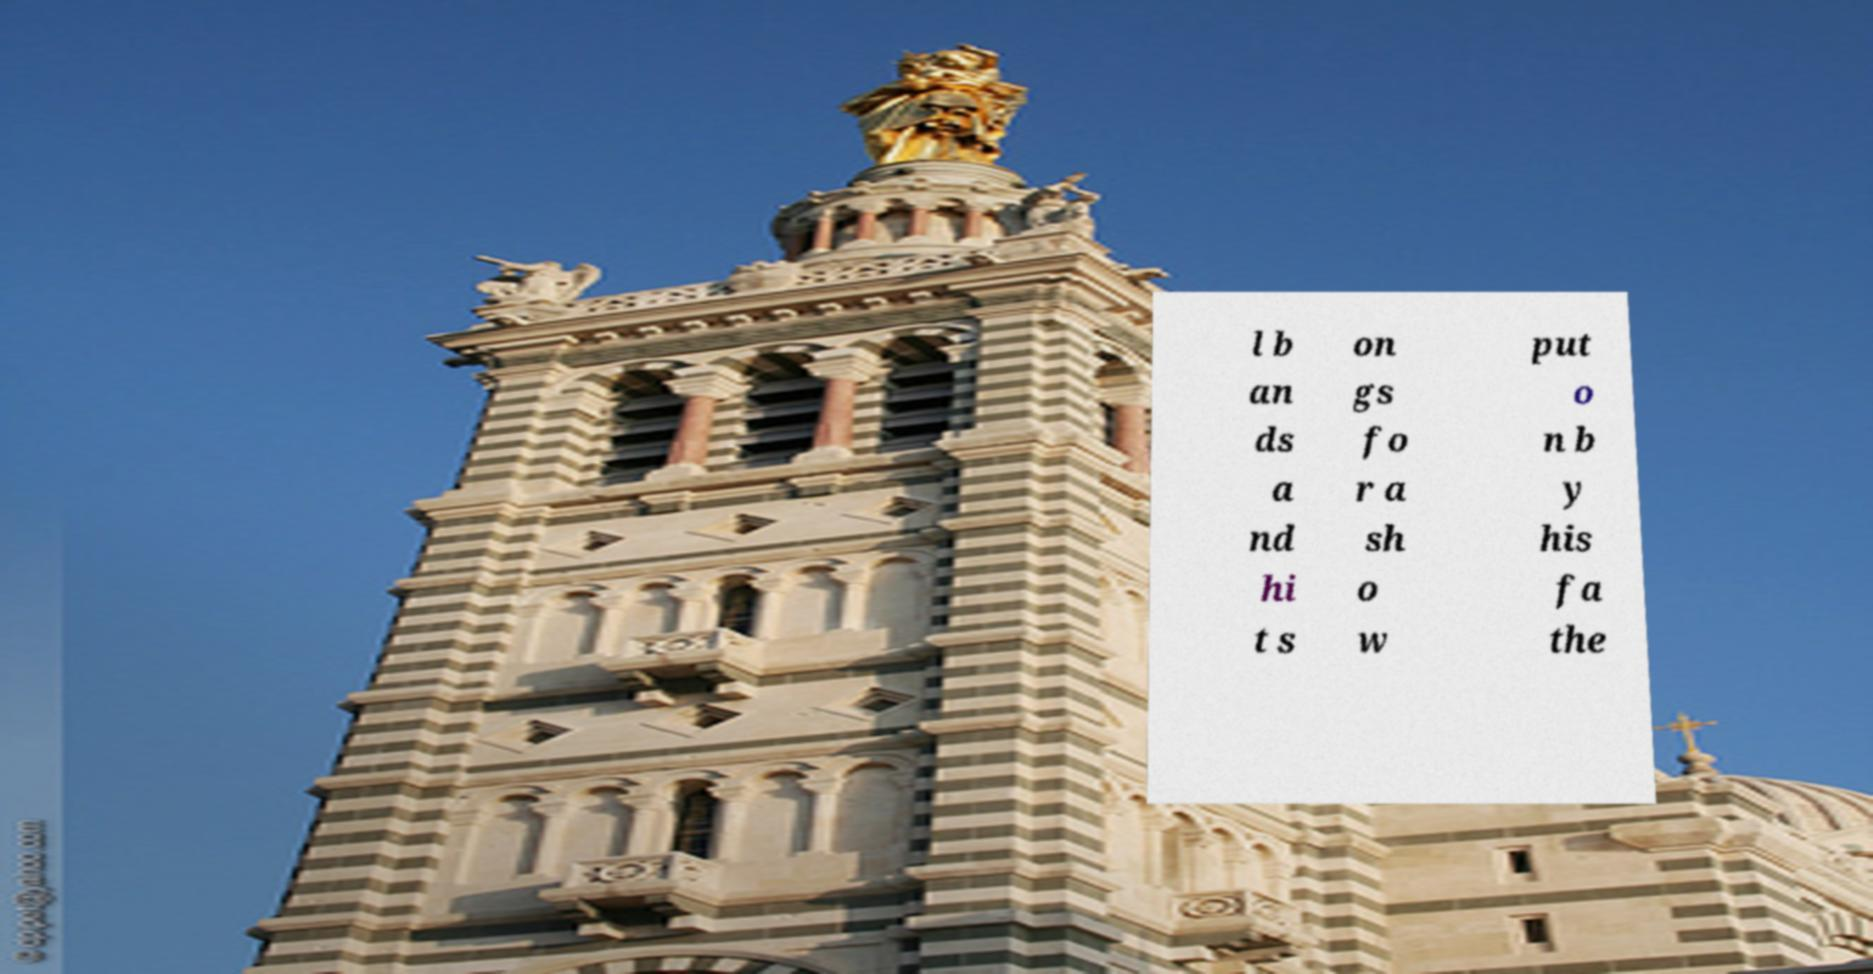Can you accurately transcribe the text from the provided image for me? l b an ds a nd hi t s on gs fo r a sh o w put o n b y his fa the 